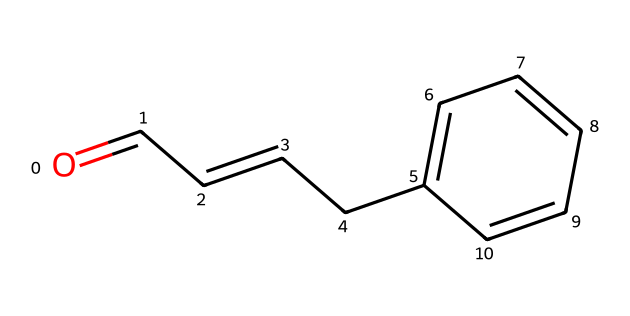What is the molecular formula of cinnamaldehyde? By examining the SMILES representation (O=CC=CCc1ccccc1), we can deduce the molecular formula by counting the atoms: there are 9 carbon (C) atoms, 8 hydrogen (H) atoms, and 1 oxygen (O) atom.
Answer: C9H8O How many rings does the structure of cinnamaldehyde contain? Looking at the SMILES, the 'c' indicates aromatic carbon atoms in a structure that forms a benzene ring. There is only one benzene ring present in the structure.
Answer: 1 What is the functional group present in cinnamaldehyde? The SMILES shows the presence of a carbonyl (C=O) group at the beginning, indicating that this compound is an aldehyde due to the carbonyl being at the end of the carbon chain.
Answer: aldehyde How many conjugated double bonds are in cinnamaldehyde? The structure contains one double bond in the carbon chain (C=CC) and another in the carbonyl (C=O), indicating two conjugated double bonds total.
Answer: 2 What type of scent is associated with cinnamaldehyde? Cinnamaldehyde is known for its sweet, warm scent reminiscent of cinnamon, which is also the primary flavoring associated with many desserts including cannoli.
Answer: sweet Is cinnamaldehyde likely to be found in flavors used in baking? Given its sweet and aromatic qualities, cinnamaldehyde is commonly used in flavorings and fragrances, especially in baked goods and confections.
Answer: yes 